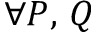<formula> <loc_0><loc_0><loc_500><loc_500>\forall P , \, Q</formula> 